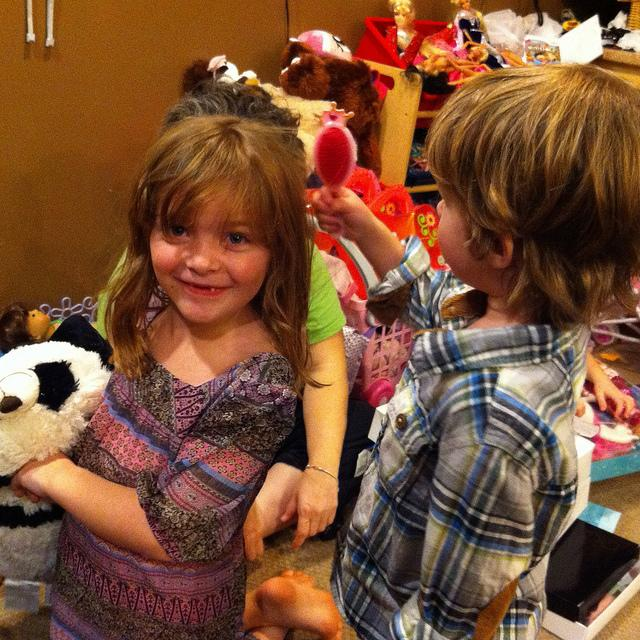What is the design called on the boy's shirt? plaid 